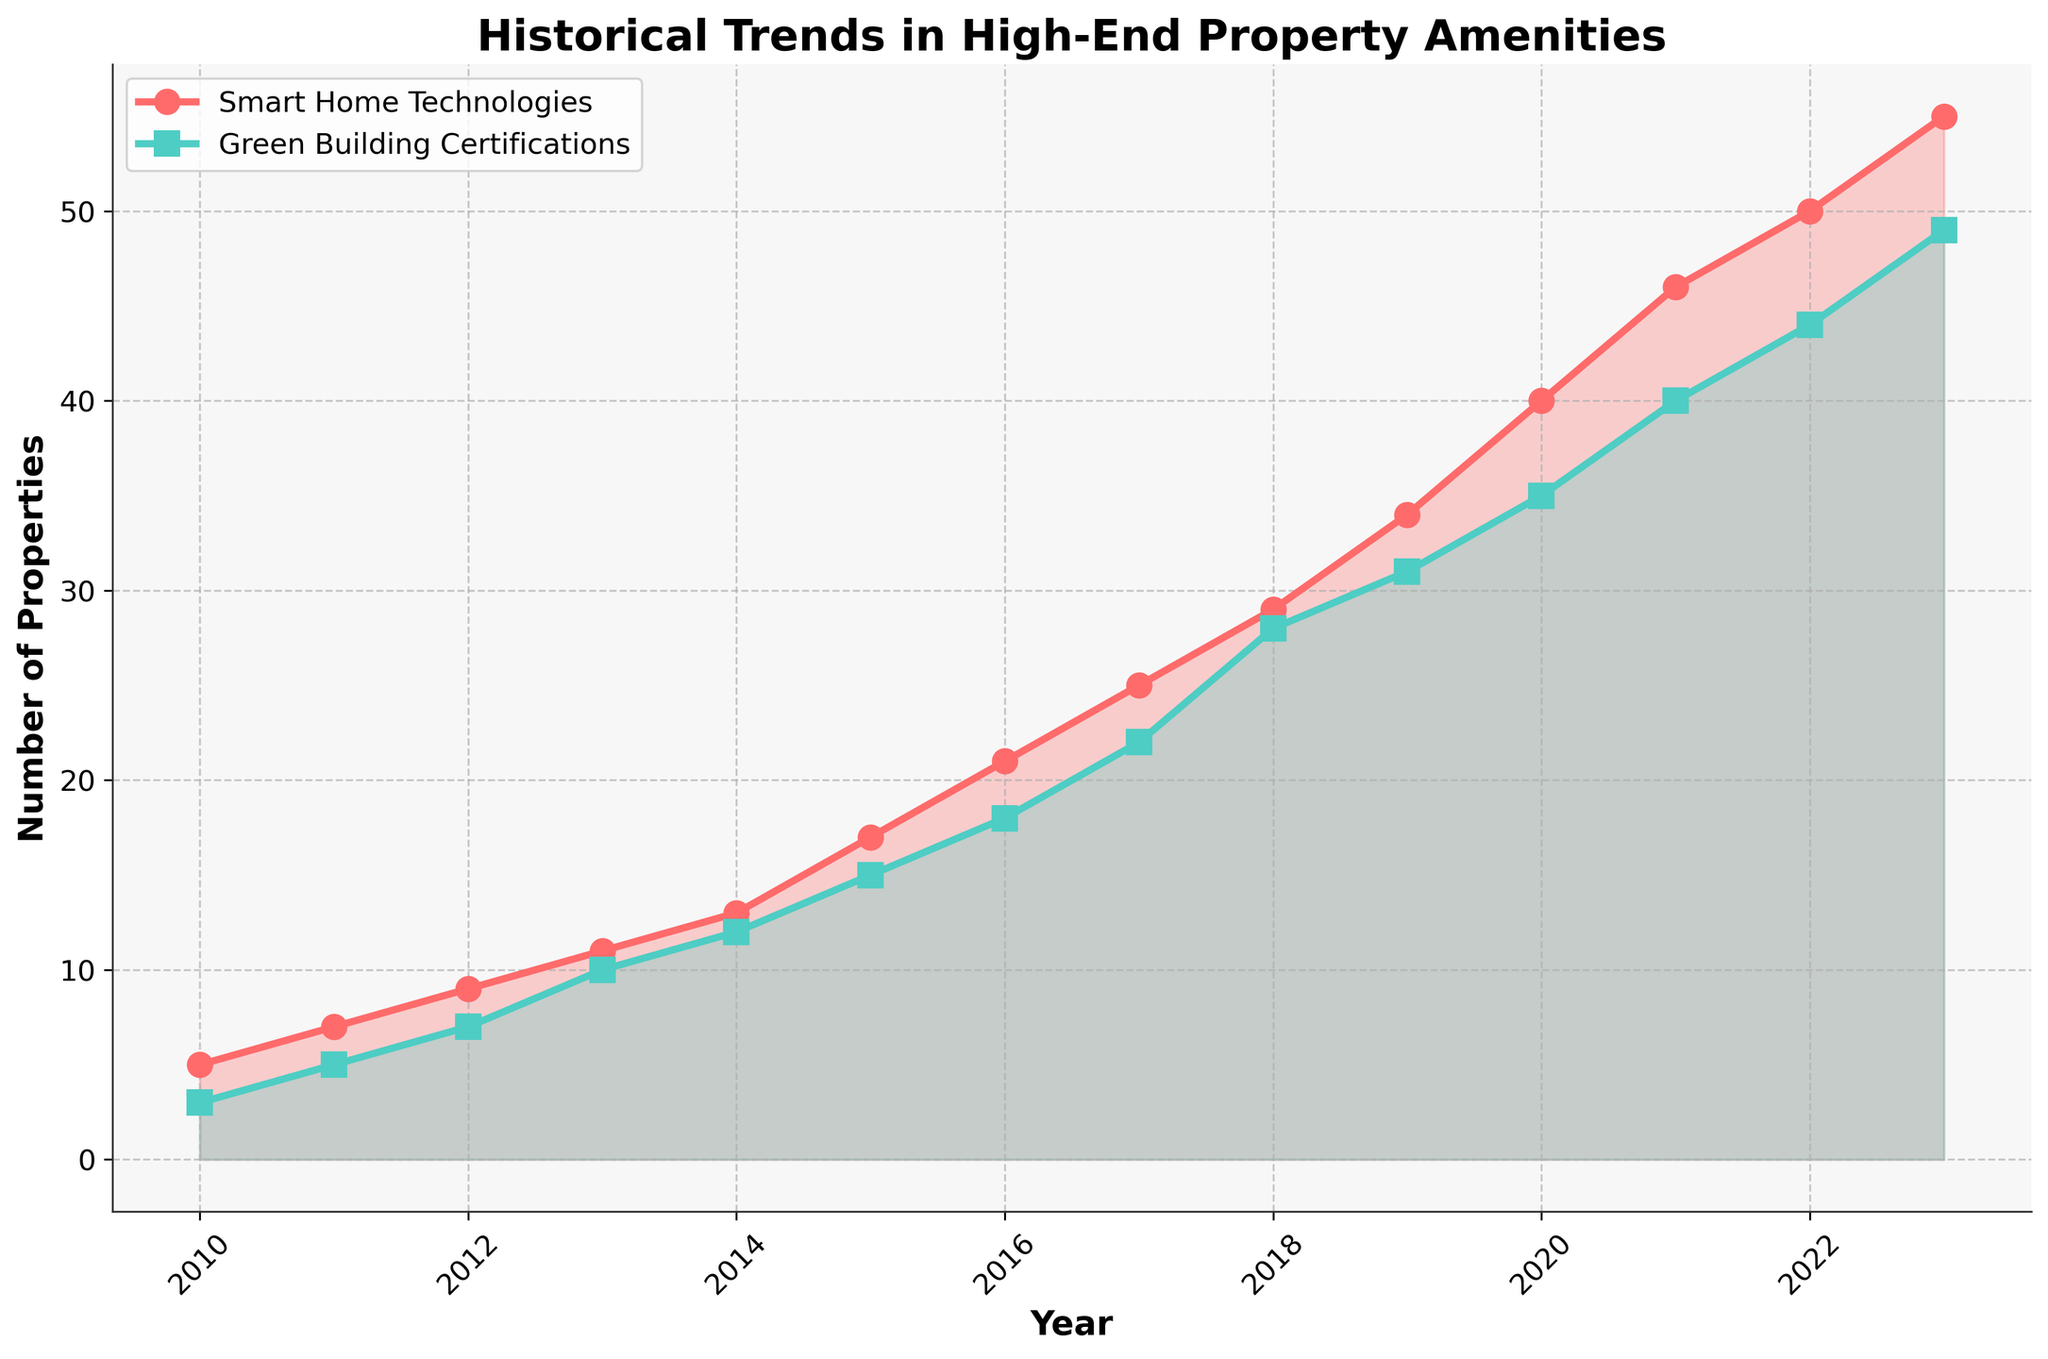What is the title of the figure? The title is usually written at the top of the figure and conveys the main topic the figure deals with.
Answer: Historical Trends in High-End Property Amenities How many years of data are shown in the figure? The x-axis represents the years. Counting the tick marks from 2010 to 2023 gives 14 years of data.
Answer: 14 What were the numbers for Smart Home Technologies and Green Building Certifications in 2012? Locate the points on both lines corresponding to the year 2012. Smart Home Technologies is 9, and Green Building Certifications is 7 in 2012.
Answer: 9 and 7 Which year saw the greatest increase in Smart Home Technologies compared to the previous year? Calculate the differences between consecutive years for Smart Home Technologies. The largest difference is between 2019 and 2020, increasing by 6 (40 - 34).
Answer: 2019 to 2020 What visual elements are used to represent Smart Home Technologies and Green Building Certifications? Identify the markers and colors for each line. Smart Home Technologies are represented by red circles (o) and Green Building Certifications by green squares (s).
Answer: Red circles and green squares When did the number of Green Building Certifications first reach 40? Check the point on the Green Building Certifications line that first aligns with the 40 mark on the y-axis, which is 2021.
Answer: 2021 In which year do Smart Home Technologies and Green Building Certifications have the same value? Identify the point where both lines intersect. They never actually intersect, but the closest values are in 2013 with Smart Home Technologies at 11 and Green Building Certifications at 10.
Answer: None, closest in 2013 By how much did the number of Smart Home Technologies increase from 2010 to 2023? Subtract the 2010 value from the 2023 value. For Smart Home Technologies: 55 - 5 = 50.
Answer: 50 Which trend line shows a consistent increase every year without any drops? Observe the continuity of the lines for both amenities. Both lines consistently increase without any drops.
Answer: Both What is the difference in the number of properties with Green Building Certifications between 2015 and 2022? Subtract the 2015 value from the 2022 value for Green Building Certifications: 44 - 15 = 29.
Answer: 29 